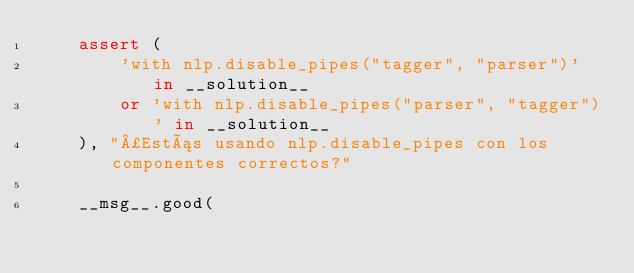Convert code to text. <code><loc_0><loc_0><loc_500><loc_500><_Python_>    assert (
        'with nlp.disable_pipes("tagger", "parser")' in __solution__
        or 'with nlp.disable_pipes("parser", "tagger")' in __solution__
    ), "¿Estás usando nlp.disable_pipes con los componentes correctos?"

    __msg__.good(</code> 